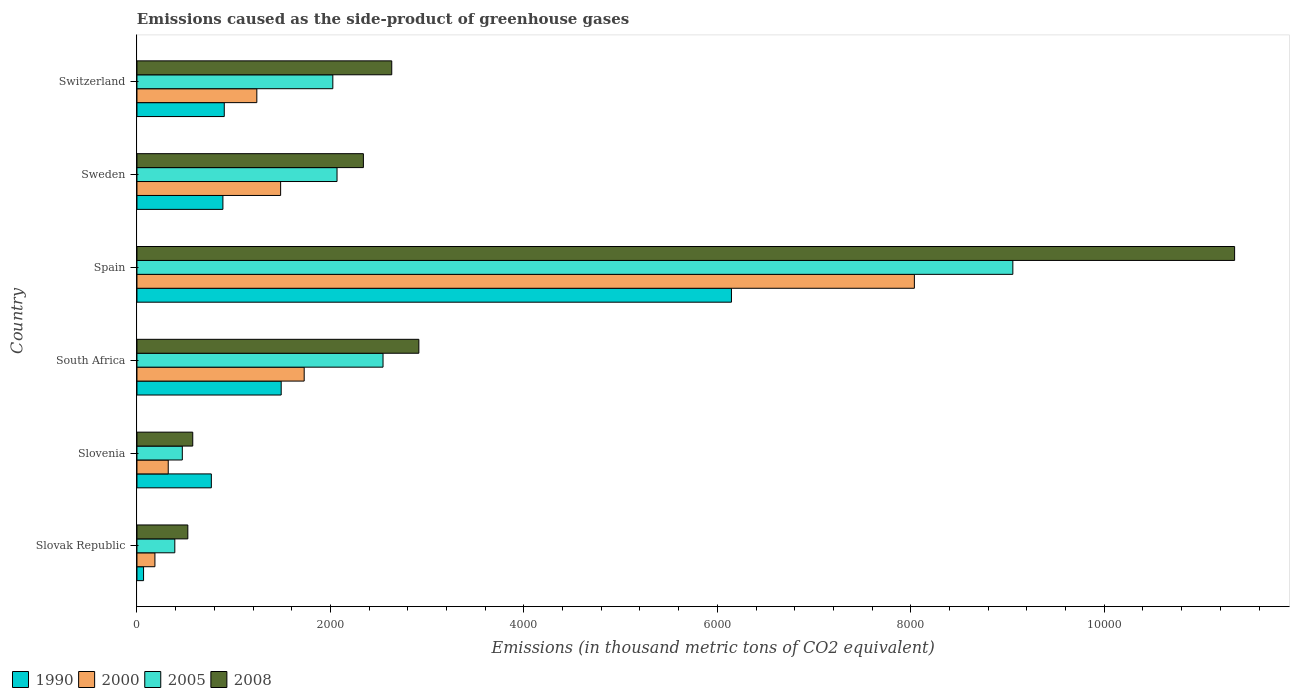How many different coloured bars are there?
Your answer should be compact. 4. Are the number of bars per tick equal to the number of legend labels?
Keep it short and to the point. Yes. How many bars are there on the 6th tick from the top?
Make the answer very short. 4. What is the label of the 6th group of bars from the top?
Your answer should be compact. Slovak Republic. In how many cases, is the number of bars for a given country not equal to the number of legend labels?
Ensure brevity in your answer.  0. What is the emissions caused as the side-product of greenhouse gases in 2005 in Switzerland?
Ensure brevity in your answer.  2025. Across all countries, what is the maximum emissions caused as the side-product of greenhouse gases in 1990?
Your answer should be compact. 6146. Across all countries, what is the minimum emissions caused as the side-product of greenhouse gases in 1990?
Your response must be concise. 68.3. In which country was the emissions caused as the side-product of greenhouse gases in 2008 maximum?
Your answer should be very brief. Spain. In which country was the emissions caused as the side-product of greenhouse gases in 1990 minimum?
Keep it short and to the point. Slovak Republic. What is the total emissions caused as the side-product of greenhouse gases in 2000 in the graph?
Provide a succinct answer. 1.30e+04. What is the difference between the emissions caused as the side-product of greenhouse gases in 2008 in Slovenia and that in Sweden?
Give a very brief answer. -1764.2. What is the difference between the emissions caused as the side-product of greenhouse gases in 2000 in Slovenia and the emissions caused as the side-product of greenhouse gases in 2008 in South Africa?
Your answer should be compact. -2591.1. What is the average emissions caused as the side-product of greenhouse gases in 2005 per country?
Your answer should be very brief. 2758.78. What is the difference between the emissions caused as the side-product of greenhouse gases in 2005 and emissions caused as the side-product of greenhouse gases in 2008 in Slovenia?
Provide a succinct answer. -107.8. In how many countries, is the emissions caused as the side-product of greenhouse gases in 2000 greater than 9200 thousand metric tons?
Provide a short and direct response. 0. What is the ratio of the emissions caused as the side-product of greenhouse gases in 1990 in Slovenia to that in South Africa?
Keep it short and to the point. 0.52. Is the emissions caused as the side-product of greenhouse gases in 2008 in Spain less than that in Switzerland?
Offer a very short reply. No. Is the difference between the emissions caused as the side-product of greenhouse gases in 2005 in Slovenia and Switzerland greater than the difference between the emissions caused as the side-product of greenhouse gases in 2008 in Slovenia and Switzerland?
Your response must be concise. Yes. What is the difference between the highest and the second highest emissions caused as the side-product of greenhouse gases in 2000?
Offer a terse response. 6308.3. What is the difference between the highest and the lowest emissions caused as the side-product of greenhouse gases in 1990?
Your answer should be very brief. 6077.7. Is the sum of the emissions caused as the side-product of greenhouse gases in 2000 in Spain and Sweden greater than the maximum emissions caused as the side-product of greenhouse gases in 2005 across all countries?
Provide a succinct answer. Yes. Is it the case that in every country, the sum of the emissions caused as the side-product of greenhouse gases in 2008 and emissions caused as the side-product of greenhouse gases in 1990 is greater than the sum of emissions caused as the side-product of greenhouse gases in 2005 and emissions caused as the side-product of greenhouse gases in 2000?
Keep it short and to the point. No. What does the 3rd bar from the bottom in Slovenia represents?
Keep it short and to the point. 2005. Is it the case that in every country, the sum of the emissions caused as the side-product of greenhouse gases in 1990 and emissions caused as the side-product of greenhouse gases in 2000 is greater than the emissions caused as the side-product of greenhouse gases in 2008?
Your response must be concise. No. How are the legend labels stacked?
Give a very brief answer. Horizontal. What is the title of the graph?
Your response must be concise. Emissions caused as the side-product of greenhouse gases. What is the label or title of the X-axis?
Ensure brevity in your answer.  Emissions (in thousand metric tons of CO2 equivalent). What is the Emissions (in thousand metric tons of CO2 equivalent) in 1990 in Slovak Republic?
Give a very brief answer. 68.3. What is the Emissions (in thousand metric tons of CO2 equivalent) of 2000 in Slovak Republic?
Offer a terse response. 185.6. What is the Emissions (in thousand metric tons of CO2 equivalent) of 2005 in Slovak Republic?
Ensure brevity in your answer.  391.3. What is the Emissions (in thousand metric tons of CO2 equivalent) in 2008 in Slovak Republic?
Provide a short and direct response. 525.8. What is the Emissions (in thousand metric tons of CO2 equivalent) in 1990 in Slovenia?
Offer a very short reply. 769. What is the Emissions (in thousand metric tons of CO2 equivalent) in 2000 in Slovenia?
Give a very brief answer. 323.3. What is the Emissions (in thousand metric tons of CO2 equivalent) in 2005 in Slovenia?
Offer a terse response. 468.9. What is the Emissions (in thousand metric tons of CO2 equivalent) of 2008 in Slovenia?
Offer a terse response. 576.7. What is the Emissions (in thousand metric tons of CO2 equivalent) of 1990 in South Africa?
Provide a short and direct response. 1491.1. What is the Emissions (in thousand metric tons of CO2 equivalent) of 2000 in South Africa?
Your answer should be compact. 1728.8. What is the Emissions (in thousand metric tons of CO2 equivalent) of 2005 in South Africa?
Keep it short and to the point. 2544. What is the Emissions (in thousand metric tons of CO2 equivalent) of 2008 in South Africa?
Provide a succinct answer. 2914.4. What is the Emissions (in thousand metric tons of CO2 equivalent) of 1990 in Spain?
Your answer should be very brief. 6146. What is the Emissions (in thousand metric tons of CO2 equivalent) of 2000 in Spain?
Offer a very short reply. 8037.1. What is the Emissions (in thousand metric tons of CO2 equivalent) of 2005 in Spain?
Offer a terse response. 9055.1. What is the Emissions (in thousand metric tons of CO2 equivalent) of 2008 in Spain?
Your answer should be very brief. 1.13e+04. What is the Emissions (in thousand metric tons of CO2 equivalent) of 1990 in Sweden?
Ensure brevity in your answer.  888.6. What is the Emissions (in thousand metric tons of CO2 equivalent) in 2000 in Sweden?
Provide a short and direct response. 1485.3. What is the Emissions (in thousand metric tons of CO2 equivalent) in 2005 in Sweden?
Give a very brief answer. 2068.4. What is the Emissions (in thousand metric tons of CO2 equivalent) of 2008 in Sweden?
Your answer should be compact. 2340.9. What is the Emissions (in thousand metric tons of CO2 equivalent) in 1990 in Switzerland?
Your response must be concise. 902.6. What is the Emissions (in thousand metric tons of CO2 equivalent) of 2000 in Switzerland?
Offer a terse response. 1239.2. What is the Emissions (in thousand metric tons of CO2 equivalent) of 2005 in Switzerland?
Your answer should be compact. 2025. What is the Emissions (in thousand metric tons of CO2 equivalent) in 2008 in Switzerland?
Provide a succinct answer. 2634.1. Across all countries, what is the maximum Emissions (in thousand metric tons of CO2 equivalent) of 1990?
Your answer should be very brief. 6146. Across all countries, what is the maximum Emissions (in thousand metric tons of CO2 equivalent) of 2000?
Your answer should be compact. 8037.1. Across all countries, what is the maximum Emissions (in thousand metric tons of CO2 equivalent) of 2005?
Make the answer very short. 9055.1. Across all countries, what is the maximum Emissions (in thousand metric tons of CO2 equivalent) of 2008?
Your response must be concise. 1.13e+04. Across all countries, what is the minimum Emissions (in thousand metric tons of CO2 equivalent) in 1990?
Keep it short and to the point. 68.3. Across all countries, what is the minimum Emissions (in thousand metric tons of CO2 equivalent) in 2000?
Your response must be concise. 185.6. Across all countries, what is the minimum Emissions (in thousand metric tons of CO2 equivalent) in 2005?
Keep it short and to the point. 391.3. Across all countries, what is the minimum Emissions (in thousand metric tons of CO2 equivalent) in 2008?
Keep it short and to the point. 525.8. What is the total Emissions (in thousand metric tons of CO2 equivalent) in 1990 in the graph?
Offer a very short reply. 1.03e+04. What is the total Emissions (in thousand metric tons of CO2 equivalent) in 2000 in the graph?
Provide a succinct answer. 1.30e+04. What is the total Emissions (in thousand metric tons of CO2 equivalent) of 2005 in the graph?
Your response must be concise. 1.66e+04. What is the total Emissions (in thousand metric tons of CO2 equivalent) of 2008 in the graph?
Your answer should be very brief. 2.03e+04. What is the difference between the Emissions (in thousand metric tons of CO2 equivalent) in 1990 in Slovak Republic and that in Slovenia?
Provide a succinct answer. -700.7. What is the difference between the Emissions (in thousand metric tons of CO2 equivalent) in 2000 in Slovak Republic and that in Slovenia?
Ensure brevity in your answer.  -137.7. What is the difference between the Emissions (in thousand metric tons of CO2 equivalent) in 2005 in Slovak Republic and that in Slovenia?
Your answer should be very brief. -77.6. What is the difference between the Emissions (in thousand metric tons of CO2 equivalent) in 2008 in Slovak Republic and that in Slovenia?
Provide a short and direct response. -50.9. What is the difference between the Emissions (in thousand metric tons of CO2 equivalent) in 1990 in Slovak Republic and that in South Africa?
Make the answer very short. -1422.8. What is the difference between the Emissions (in thousand metric tons of CO2 equivalent) in 2000 in Slovak Republic and that in South Africa?
Provide a short and direct response. -1543.2. What is the difference between the Emissions (in thousand metric tons of CO2 equivalent) in 2005 in Slovak Republic and that in South Africa?
Ensure brevity in your answer.  -2152.7. What is the difference between the Emissions (in thousand metric tons of CO2 equivalent) of 2008 in Slovak Republic and that in South Africa?
Provide a succinct answer. -2388.6. What is the difference between the Emissions (in thousand metric tons of CO2 equivalent) of 1990 in Slovak Republic and that in Spain?
Keep it short and to the point. -6077.7. What is the difference between the Emissions (in thousand metric tons of CO2 equivalent) in 2000 in Slovak Republic and that in Spain?
Provide a short and direct response. -7851.5. What is the difference between the Emissions (in thousand metric tons of CO2 equivalent) of 2005 in Slovak Republic and that in Spain?
Give a very brief answer. -8663.8. What is the difference between the Emissions (in thousand metric tons of CO2 equivalent) in 2008 in Slovak Republic and that in Spain?
Ensure brevity in your answer.  -1.08e+04. What is the difference between the Emissions (in thousand metric tons of CO2 equivalent) of 1990 in Slovak Republic and that in Sweden?
Provide a short and direct response. -820.3. What is the difference between the Emissions (in thousand metric tons of CO2 equivalent) in 2000 in Slovak Republic and that in Sweden?
Offer a terse response. -1299.7. What is the difference between the Emissions (in thousand metric tons of CO2 equivalent) of 2005 in Slovak Republic and that in Sweden?
Make the answer very short. -1677.1. What is the difference between the Emissions (in thousand metric tons of CO2 equivalent) in 2008 in Slovak Republic and that in Sweden?
Give a very brief answer. -1815.1. What is the difference between the Emissions (in thousand metric tons of CO2 equivalent) in 1990 in Slovak Republic and that in Switzerland?
Your response must be concise. -834.3. What is the difference between the Emissions (in thousand metric tons of CO2 equivalent) in 2000 in Slovak Republic and that in Switzerland?
Keep it short and to the point. -1053.6. What is the difference between the Emissions (in thousand metric tons of CO2 equivalent) in 2005 in Slovak Republic and that in Switzerland?
Offer a very short reply. -1633.7. What is the difference between the Emissions (in thousand metric tons of CO2 equivalent) of 2008 in Slovak Republic and that in Switzerland?
Your answer should be compact. -2108.3. What is the difference between the Emissions (in thousand metric tons of CO2 equivalent) of 1990 in Slovenia and that in South Africa?
Offer a very short reply. -722.1. What is the difference between the Emissions (in thousand metric tons of CO2 equivalent) of 2000 in Slovenia and that in South Africa?
Provide a succinct answer. -1405.5. What is the difference between the Emissions (in thousand metric tons of CO2 equivalent) in 2005 in Slovenia and that in South Africa?
Give a very brief answer. -2075.1. What is the difference between the Emissions (in thousand metric tons of CO2 equivalent) of 2008 in Slovenia and that in South Africa?
Make the answer very short. -2337.7. What is the difference between the Emissions (in thousand metric tons of CO2 equivalent) in 1990 in Slovenia and that in Spain?
Your answer should be compact. -5377. What is the difference between the Emissions (in thousand metric tons of CO2 equivalent) in 2000 in Slovenia and that in Spain?
Your answer should be very brief. -7713.8. What is the difference between the Emissions (in thousand metric tons of CO2 equivalent) in 2005 in Slovenia and that in Spain?
Provide a succinct answer. -8586.2. What is the difference between the Emissions (in thousand metric tons of CO2 equivalent) in 2008 in Slovenia and that in Spain?
Keep it short and to the point. -1.08e+04. What is the difference between the Emissions (in thousand metric tons of CO2 equivalent) in 1990 in Slovenia and that in Sweden?
Offer a very short reply. -119.6. What is the difference between the Emissions (in thousand metric tons of CO2 equivalent) of 2000 in Slovenia and that in Sweden?
Your response must be concise. -1162. What is the difference between the Emissions (in thousand metric tons of CO2 equivalent) in 2005 in Slovenia and that in Sweden?
Offer a very short reply. -1599.5. What is the difference between the Emissions (in thousand metric tons of CO2 equivalent) of 2008 in Slovenia and that in Sweden?
Ensure brevity in your answer.  -1764.2. What is the difference between the Emissions (in thousand metric tons of CO2 equivalent) in 1990 in Slovenia and that in Switzerland?
Provide a succinct answer. -133.6. What is the difference between the Emissions (in thousand metric tons of CO2 equivalent) in 2000 in Slovenia and that in Switzerland?
Your answer should be compact. -915.9. What is the difference between the Emissions (in thousand metric tons of CO2 equivalent) of 2005 in Slovenia and that in Switzerland?
Ensure brevity in your answer.  -1556.1. What is the difference between the Emissions (in thousand metric tons of CO2 equivalent) of 2008 in Slovenia and that in Switzerland?
Your response must be concise. -2057.4. What is the difference between the Emissions (in thousand metric tons of CO2 equivalent) in 1990 in South Africa and that in Spain?
Offer a very short reply. -4654.9. What is the difference between the Emissions (in thousand metric tons of CO2 equivalent) of 2000 in South Africa and that in Spain?
Make the answer very short. -6308.3. What is the difference between the Emissions (in thousand metric tons of CO2 equivalent) in 2005 in South Africa and that in Spain?
Ensure brevity in your answer.  -6511.1. What is the difference between the Emissions (in thousand metric tons of CO2 equivalent) in 2008 in South Africa and that in Spain?
Make the answer very short. -8433.4. What is the difference between the Emissions (in thousand metric tons of CO2 equivalent) in 1990 in South Africa and that in Sweden?
Keep it short and to the point. 602.5. What is the difference between the Emissions (in thousand metric tons of CO2 equivalent) in 2000 in South Africa and that in Sweden?
Offer a very short reply. 243.5. What is the difference between the Emissions (in thousand metric tons of CO2 equivalent) of 2005 in South Africa and that in Sweden?
Your response must be concise. 475.6. What is the difference between the Emissions (in thousand metric tons of CO2 equivalent) of 2008 in South Africa and that in Sweden?
Ensure brevity in your answer.  573.5. What is the difference between the Emissions (in thousand metric tons of CO2 equivalent) in 1990 in South Africa and that in Switzerland?
Give a very brief answer. 588.5. What is the difference between the Emissions (in thousand metric tons of CO2 equivalent) of 2000 in South Africa and that in Switzerland?
Make the answer very short. 489.6. What is the difference between the Emissions (in thousand metric tons of CO2 equivalent) of 2005 in South Africa and that in Switzerland?
Give a very brief answer. 519. What is the difference between the Emissions (in thousand metric tons of CO2 equivalent) in 2008 in South Africa and that in Switzerland?
Ensure brevity in your answer.  280.3. What is the difference between the Emissions (in thousand metric tons of CO2 equivalent) of 1990 in Spain and that in Sweden?
Make the answer very short. 5257.4. What is the difference between the Emissions (in thousand metric tons of CO2 equivalent) of 2000 in Spain and that in Sweden?
Make the answer very short. 6551.8. What is the difference between the Emissions (in thousand metric tons of CO2 equivalent) in 2005 in Spain and that in Sweden?
Your response must be concise. 6986.7. What is the difference between the Emissions (in thousand metric tons of CO2 equivalent) in 2008 in Spain and that in Sweden?
Offer a terse response. 9006.9. What is the difference between the Emissions (in thousand metric tons of CO2 equivalent) in 1990 in Spain and that in Switzerland?
Offer a terse response. 5243.4. What is the difference between the Emissions (in thousand metric tons of CO2 equivalent) of 2000 in Spain and that in Switzerland?
Your response must be concise. 6797.9. What is the difference between the Emissions (in thousand metric tons of CO2 equivalent) of 2005 in Spain and that in Switzerland?
Keep it short and to the point. 7030.1. What is the difference between the Emissions (in thousand metric tons of CO2 equivalent) in 2008 in Spain and that in Switzerland?
Provide a short and direct response. 8713.7. What is the difference between the Emissions (in thousand metric tons of CO2 equivalent) in 1990 in Sweden and that in Switzerland?
Your answer should be very brief. -14. What is the difference between the Emissions (in thousand metric tons of CO2 equivalent) in 2000 in Sweden and that in Switzerland?
Offer a terse response. 246.1. What is the difference between the Emissions (in thousand metric tons of CO2 equivalent) of 2005 in Sweden and that in Switzerland?
Your response must be concise. 43.4. What is the difference between the Emissions (in thousand metric tons of CO2 equivalent) in 2008 in Sweden and that in Switzerland?
Your answer should be compact. -293.2. What is the difference between the Emissions (in thousand metric tons of CO2 equivalent) in 1990 in Slovak Republic and the Emissions (in thousand metric tons of CO2 equivalent) in 2000 in Slovenia?
Give a very brief answer. -255. What is the difference between the Emissions (in thousand metric tons of CO2 equivalent) of 1990 in Slovak Republic and the Emissions (in thousand metric tons of CO2 equivalent) of 2005 in Slovenia?
Your answer should be compact. -400.6. What is the difference between the Emissions (in thousand metric tons of CO2 equivalent) in 1990 in Slovak Republic and the Emissions (in thousand metric tons of CO2 equivalent) in 2008 in Slovenia?
Your answer should be compact. -508.4. What is the difference between the Emissions (in thousand metric tons of CO2 equivalent) in 2000 in Slovak Republic and the Emissions (in thousand metric tons of CO2 equivalent) in 2005 in Slovenia?
Give a very brief answer. -283.3. What is the difference between the Emissions (in thousand metric tons of CO2 equivalent) of 2000 in Slovak Republic and the Emissions (in thousand metric tons of CO2 equivalent) of 2008 in Slovenia?
Give a very brief answer. -391.1. What is the difference between the Emissions (in thousand metric tons of CO2 equivalent) of 2005 in Slovak Republic and the Emissions (in thousand metric tons of CO2 equivalent) of 2008 in Slovenia?
Ensure brevity in your answer.  -185.4. What is the difference between the Emissions (in thousand metric tons of CO2 equivalent) of 1990 in Slovak Republic and the Emissions (in thousand metric tons of CO2 equivalent) of 2000 in South Africa?
Your response must be concise. -1660.5. What is the difference between the Emissions (in thousand metric tons of CO2 equivalent) of 1990 in Slovak Republic and the Emissions (in thousand metric tons of CO2 equivalent) of 2005 in South Africa?
Your response must be concise. -2475.7. What is the difference between the Emissions (in thousand metric tons of CO2 equivalent) of 1990 in Slovak Republic and the Emissions (in thousand metric tons of CO2 equivalent) of 2008 in South Africa?
Your response must be concise. -2846.1. What is the difference between the Emissions (in thousand metric tons of CO2 equivalent) of 2000 in Slovak Republic and the Emissions (in thousand metric tons of CO2 equivalent) of 2005 in South Africa?
Provide a short and direct response. -2358.4. What is the difference between the Emissions (in thousand metric tons of CO2 equivalent) in 2000 in Slovak Republic and the Emissions (in thousand metric tons of CO2 equivalent) in 2008 in South Africa?
Your answer should be compact. -2728.8. What is the difference between the Emissions (in thousand metric tons of CO2 equivalent) of 2005 in Slovak Republic and the Emissions (in thousand metric tons of CO2 equivalent) of 2008 in South Africa?
Keep it short and to the point. -2523.1. What is the difference between the Emissions (in thousand metric tons of CO2 equivalent) in 1990 in Slovak Republic and the Emissions (in thousand metric tons of CO2 equivalent) in 2000 in Spain?
Your answer should be compact. -7968.8. What is the difference between the Emissions (in thousand metric tons of CO2 equivalent) in 1990 in Slovak Republic and the Emissions (in thousand metric tons of CO2 equivalent) in 2005 in Spain?
Give a very brief answer. -8986.8. What is the difference between the Emissions (in thousand metric tons of CO2 equivalent) in 1990 in Slovak Republic and the Emissions (in thousand metric tons of CO2 equivalent) in 2008 in Spain?
Your answer should be compact. -1.13e+04. What is the difference between the Emissions (in thousand metric tons of CO2 equivalent) of 2000 in Slovak Republic and the Emissions (in thousand metric tons of CO2 equivalent) of 2005 in Spain?
Your answer should be very brief. -8869.5. What is the difference between the Emissions (in thousand metric tons of CO2 equivalent) of 2000 in Slovak Republic and the Emissions (in thousand metric tons of CO2 equivalent) of 2008 in Spain?
Your answer should be compact. -1.12e+04. What is the difference between the Emissions (in thousand metric tons of CO2 equivalent) of 2005 in Slovak Republic and the Emissions (in thousand metric tons of CO2 equivalent) of 2008 in Spain?
Offer a very short reply. -1.10e+04. What is the difference between the Emissions (in thousand metric tons of CO2 equivalent) of 1990 in Slovak Republic and the Emissions (in thousand metric tons of CO2 equivalent) of 2000 in Sweden?
Make the answer very short. -1417. What is the difference between the Emissions (in thousand metric tons of CO2 equivalent) in 1990 in Slovak Republic and the Emissions (in thousand metric tons of CO2 equivalent) in 2005 in Sweden?
Provide a succinct answer. -2000.1. What is the difference between the Emissions (in thousand metric tons of CO2 equivalent) of 1990 in Slovak Republic and the Emissions (in thousand metric tons of CO2 equivalent) of 2008 in Sweden?
Offer a very short reply. -2272.6. What is the difference between the Emissions (in thousand metric tons of CO2 equivalent) in 2000 in Slovak Republic and the Emissions (in thousand metric tons of CO2 equivalent) in 2005 in Sweden?
Ensure brevity in your answer.  -1882.8. What is the difference between the Emissions (in thousand metric tons of CO2 equivalent) of 2000 in Slovak Republic and the Emissions (in thousand metric tons of CO2 equivalent) of 2008 in Sweden?
Offer a very short reply. -2155.3. What is the difference between the Emissions (in thousand metric tons of CO2 equivalent) of 2005 in Slovak Republic and the Emissions (in thousand metric tons of CO2 equivalent) of 2008 in Sweden?
Provide a short and direct response. -1949.6. What is the difference between the Emissions (in thousand metric tons of CO2 equivalent) in 1990 in Slovak Republic and the Emissions (in thousand metric tons of CO2 equivalent) in 2000 in Switzerland?
Offer a very short reply. -1170.9. What is the difference between the Emissions (in thousand metric tons of CO2 equivalent) in 1990 in Slovak Republic and the Emissions (in thousand metric tons of CO2 equivalent) in 2005 in Switzerland?
Offer a very short reply. -1956.7. What is the difference between the Emissions (in thousand metric tons of CO2 equivalent) in 1990 in Slovak Republic and the Emissions (in thousand metric tons of CO2 equivalent) in 2008 in Switzerland?
Keep it short and to the point. -2565.8. What is the difference between the Emissions (in thousand metric tons of CO2 equivalent) in 2000 in Slovak Republic and the Emissions (in thousand metric tons of CO2 equivalent) in 2005 in Switzerland?
Your response must be concise. -1839.4. What is the difference between the Emissions (in thousand metric tons of CO2 equivalent) in 2000 in Slovak Republic and the Emissions (in thousand metric tons of CO2 equivalent) in 2008 in Switzerland?
Your response must be concise. -2448.5. What is the difference between the Emissions (in thousand metric tons of CO2 equivalent) in 2005 in Slovak Republic and the Emissions (in thousand metric tons of CO2 equivalent) in 2008 in Switzerland?
Your response must be concise. -2242.8. What is the difference between the Emissions (in thousand metric tons of CO2 equivalent) of 1990 in Slovenia and the Emissions (in thousand metric tons of CO2 equivalent) of 2000 in South Africa?
Your answer should be very brief. -959.8. What is the difference between the Emissions (in thousand metric tons of CO2 equivalent) in 1990 in Slovenia and the Emissions (in thousand metric tons of CO2 equivalent) in 2005 in South Africa?
Make the answer very short. -1775. What is the difference between the Emissions (in thousand metric tons of CO2 equivalent) in 1990 in Slovenia and the Emissions (in thousand metric tons of CO2 equivalent) in 2008 in South Africa?
Offer a very short reply. -2145.4. What is the difference between the Emissions (in thousand metric tons of CO2 equivalent) in 2000 in Slovenia and the Emissions (in thousand metric tons of CO2 equivalent) in 2005 in South Africa?
Provide a short and direct response. -2220.7. What is the difference between the Emissions (in thousand metric tons of CO2 equivalent) in 2000 in Slovenia and the Emissions (in thousand metric tons of CO2 equivalent) in 2008 in South Africa?
Your answer should be very brief. -2591.1. What is the difference between the Emissions (in thousand metric tons of CO2 equivalent) in 2005 in Slovenia and the Emissions (in thousand metric tons of CO2 equivalent) in 2008 in South Africa?
Ensure brevity in your answer.  -2445.5. What is the difference between the Emissions (in thousand metric tons of CO2 equivalent) of 1990 in Slovenia and the Emissions (in thousand metric tons of CO2 equivalent) of 2000 in Spain?
Ensure brevity in your answer.  -7268.1. What is the difference between the Emissions (in thousand metric tons of CO2 equivalent) in 1990 in Slovenia and the Emissions (in thousand metric tons of CO2 equivalent) in 2005 in Spain?
Your answer should be compact. -8286.1. What is the difference between the Emissions (in thousand metric tons of CO2 equivalent) of 1990 in Slovenia and the Emissions (in thousand metric tons of CO2 equivalent) of 2008 in Spain?
Offer a very short reply. -1.06e+04. What is the difference between the Emissions (in thousand metric tons of CO2 equivalent) of 2000 in Slovenia and the Emissions (in thousand metric tons of CO2 equivalent) of 2005 in Spain?
Offer a terse response. -8731.8. What is the difference between the Emissions (in thousand metric tons of CO2 equivalent) of 2000 in Slovenia and the Emissions (in thousand metric tons of CO2 equivalent) of 2008 in Spain?
Your response must be concise. -1.10e+04. What is the difference between the Emissions (in thousand metric tons of CO2 equivalent) of 2005 in Slovenia and the Emissions (in thousand metric tons of CO2 equivalent) of 2008 in Spain?
Your answer should be very brief. -1.09e+04. What is the difference between the Emissions (in thousand metric tons of CO2 equivalent) in 1990 in Slovenia and the Emissions (in thousand metric tons of CO2 equivalent) in 2000 in Sweden?
Provide a short and direct response. -716.3. What is the difference between the Emissions (in thousand metric tons of CO2 equivalent) of 1990 in Slovenia and the Emissions (in thousand metric tons of CO2 equivalent) of 2005 in Sweden?
Your answer should be compact. -1299.4. What is the difference between the Emissions (in thousand metric tons of CO2 equivalent) in 1990 in Slovenia and the Emissions (in thousand metric tons of CO2 equivalent) in 2008 in Sweden?
Give a very brief answer. -1571.9. What is the difference between the Emissions (in thousand metric tons of CO2 equivalent) of 2000 in Slovenia and the Emissions (in thousand metric tons of CO2 equivalent) of 2005 in Sweden?
Offer a terse response. -1745.1. What is the difference between the Emissions (in thousand metric tons of CO2 equivalent) in 2000 in Slovenia and the Emissions (in thousand metric tons of CO2 equivalent) in 2008 in Sweden?
Provide a short and direct response. -2017.6. What is the difference between the Emissions (in thousand metric tons of CO2 equivalent) in 2005 in Slovenia and the Emissions (in thousand metric tons of CO2 equivalent) in 2008 in Sweden?
Ensure brevity in your answer.  -1872. What is the difference between the Emissions (in thousand metric tons of CO2 equivalent) in 1990 in Slovenia and the Emissions (in thousand metric tons of CO2 equivalent) in 2000 in Switzerland?
Offer a terse response. -470.2. What is the difference between the Emissions (in thousand metric tons of CO2 equivalent) in 1990 in Slovenia and the Emissions (in thousand metric tons of CO2 equivalent) in 2005 in Switzerland?
Make the answer very short. -1256. What is the difference between the Emissions (in thousand metric tons of CO2 equivalent) in 1990 in Slovenia and the Emissions (in thousand metric tons of CO2 equivalent) in 2008 in Switzerland?
Offer a terse response. -1865.1. What is the difference between the Emissions (in thousand metric tons of CO2 equivalent) in 2000 in Slovenia and the Emissions (in thousand metric tons of CO2 equivalent) in 2005 in Switzerland?
Offer a very short reply. -1701.7. What is the difference between the Emissions (in thousand metric tons of CO2 equivalent) of 2000 in Slovenia and the Emissions (in thousand metric tons of CO2 equivalent) of 2008 in Switzerland?
Offer a very short reply. -2310.8. What is the difference between the Emissions (in thousand metric tons of CO2 equivalent) of 2005 in Slovenia and the Emissions (in thousand metric tons of CO2 equivalent) of 2008 in Switzerland?
Give a very brief answer. -2165.2. What is the difference between the Emissions (in thousand metric tons of CO2 equivalent) in 1990 in South Africa and the Emissions (in thousand metric tons of CO2 equivalent) in 2000 in Spain?
Provide a short and direct response. -6546. What is the difference between the Emissions (in thousand metric tons of CO2 equivalent) of 1990 in South Africa and the Emissions (in thousand metric tons of CO2 equivalent) of 2005 in Spain?
Your answer should be compact. -7564. What is the difference between the Emissions (in thousand metric tons of CO2 equivalent) of 1990 in South Africa and the Emissions (in thousand metric tons of CO2 equivalent) of 2008 in Spain?
Give a very brief answer. -9856.7. What is the difference between the Emissions (in thousand metric tons of CO2 equivalent) in 2000 in South Africa and the Emissions (in thousand metric tons of CO2 equivalent) in 2005 in Spain?
Offer a very short reply. -7326.3. What is the difference between the Emissions (in thousand metric tons of CO2 equivalent) in 2000 in South Africa and the Emissions (in thousand metric tons of CO2 equivalent) in 2008 in Spain?
Make the answer very short. -9619. What is the difference between the Emissions (in thousand metric tons of CO2 equivalent) of 2005 in South Africa and the Emissions (in thousand metric tons of CO2 equivalent) of 2008 in Spain?
Offer a terse response. -8803.8. What is the difference between the Emissions (in thousand metric tons of CO2 equivalent) of 1990 in South Africa and the Emissions (in thousand metric tons of CO2 equivalent) of 2005 in Sweden?
Make the answer very short. -577.3. What is the difference between the Emissions (in thousand metric tons of CO2 equivalent) of 1990 in South Africa and the Emissions (in thousand metric tons of CO2 equivalent) of 2008 in Sweden?
Give a very brief answer. -849.8. What is the difference between the Emissions (in thousand metric tons of CO2 equivalent) of 2000 in South Africa and the Emissions (in thousand metric tons of CO2 equivalent) of 2005 in Sweden?
Keep it short and to the point. -339.6. What is the difference between the Emissions (in thousand metric tons of CO2 equivalent) in 2000 in South Africa and the Emissions (in thousand metric tons of CO2 equivalent) in 2008 in Sweden?
Offer a very short reply. -612.1. What is the difference between the Emissions (in thousand metric tons of CO2 equivalent) in 2005 in South Africa and the Emissions (in thousand metric tons of CO2 equivalent) in 2008 in Sweden?
Your response must be concise. 203.1. What is the difference between the Emissions (in thousand metric tons of CO2 equivalent) of 1990 in South Africa and the Emissions (in thousand metric tons of CO2 equivalent) of 2000 in Switzerland?
Ensure brevity in your answer.  251.9. What is the difference between the Emissions (in thousand metric tons of CO2 equivalent) of 1990 in South Africa and the Emissions (in thousand metric tons of CO2 equivalent) of 2005 in Switzerland?
Make the answer very short. -533.9. What is the difference between the Emissions (in thousand metric tons of CO2 equivalent) in 1990 in South Africa and the Emissions (in thousand metric tons of CO2 equivalent) in 2008 in Switzerland?
Give a very brief answer. -1143. What is the difference between the Emissions (in thousand metric tons of CO2 equivalent) in 2000 in South Africa and the Emissions (in thousand metric tons of CO2 equivalent) in 2005 in Switzerland?
Provide a short and direct response. -296.2. What is the difference between the Emissions (in thousand metric tons of CO2 equivalent) in 2000 in South Africa and the Emissions (in thousand metric tons of CO2 equivalent) in 2008 in Switzerland?
Your answer should be compact. -905.3. What is the difference between the Emissions (in thousand metric tons of CO2 equivalent) of 2005 in South Africa and the Emissions (in thousand metric tons of CO2 equivalent) of 2008 in Switzerland?
Ensure brevity in your answer.  -90.1. What is the difference between the Emissions (in thousand metric tons of CO2 equivalent) in 1990 in Spain and the Emissions (in thousand metric tons of CO2 equivalent) in 2000 in Sweden?
Give a very brief answer. 4660.7. What is the difference between the Emissions (in thousand metric tons of CO2 equivalent) of 1990 in Spain and the Emissions (in thousand metric tons of CO2 equivalent) of 2005 in Sweden?
Ensure brevity in your answer.  4077.6. What is the difference between the Emissions (in thousand metric tons of CO2 equivalent) of 1990 in Spain and the Emissions (in thousand metric tons of CO2 equivalent) of 2008 in Sweden?
Give a very brief answer. 3805.1. What is the difference between the Emissions (in thousand metric tons of CO2 equivalent) in 2000 in Spain and the Emissions (in thousand metric tons of CO2 equivalent) in 2005 in Sweden?
Give a very brief answer. 5968.7. What is the difference between the Emissions (in thousand metric tons of CO2 equivalent) of 2000 in Spain and the Emissions (in thousand metric tons of CO2 equivalent) of 2008 in Sweden?
Give a very brief answer. 5696.2. What is the difference between the Emissions (in thousand metric tons of CO2 equivalent) of 2005 in Spain and the Emissions (in thousand metric tons of CO2 equivalent) of 2008 in Sweden?
Give a very brief answer. 6714.2. What is the difference between the Emissions (in thousand metric tons of CO2 equivalent) of 1990 in Spain and the Emissions (in thousand metric tons of CO2 equivalent) of 2000 in Switzerland?
Ensure brevity in your answer.  4906.8. What is the difference between the Emissions (in thousand metric tons of CO2 equivalent) in 1990 in Spain and the Emissions (in thousand metric tons of CO2 equivalent) in 2005 in Switzerland?
Make the answer very short. 4121. What is the difference between the Emissions (in thousand metric tons of CO2 equivalent) of 1990 in Spain and the Emissions (in thousand metric tons of CO2 equivalent) of 2008 in Switzerland?
Your answer should be very brief. 3511.9. What is the difference between the Emissions (in thousand metric tons of CO2 equivalent) of 2000 in Spain and the Emissions (in thousand metric tons of CO2 equivalent) of 2005 in Switzerland?
Make the answer very short. 6012.1. What is the difference between the Emissions (in thousand metric tons of CO2 equivalent) in 2000 in Spain and the Emissions (in thousand metric tons of CO2 equivalent) in 2008 in Switzerland?
Offer a terse response. 5403. What is the difference between the Emissions (in thousand metric tons of CO2 equivalent) of 2005 in Spain and the Emissions (in thousand metric tons of CO2 equivalent) of 2008 in Switzerland?
Provide a succinct answer. 6421. What is the difference between the Emissions (in thousand metric tons of CO2 equivalent) in 1990 in Sweden and the Emissions (in thousand metric tons of CO2 equivalent) in 2000 in Switzerland?
Keep it short and to the point. -350.6. What is the difference between the Emissions (in thousand metric tons of CO2 equivalent) in 1990 in Sweden and the Emissions (in thousand metric tons of CO2 equivalent) in 2005 in Switzerland?
Your answer should be compact. -1136.4. What is the difference between the Emissions (in thousand metric tons of CO2 equivalent) of 1990 in Sweden and the Emissions (in thousand metric tons of CO2 equivalent) of 2008 in Switzerland?
Give a very brief answer. -1745.5. What is the difference between the Emissions (in thousand metric tons of CO2 equivalent) in 2000 in Sweden and the Emissions (in thousand metric tons of CO2 equivalent) in 2005 in Switzerland?
Your answer should be very brief. -539.7. What is the difference between the Emissions (in thousand metric tons of CO2 equivalent) in 2000 in Sweden and the Emissions (in thousand metric tons of CO2 equivalent) in 2008 in Switzerland?
Your answer should be very brief. -1148.8. What is the difference between the Emissions (in thousand metric tons of CO2 equivalent) of 2005 in Sweden and the Emissions (in thousand metric tons of CO2 equivalent) of 2008 in Switzerland?
Keep it short and to the point. -565.7. What is the average Emissions (in thousand metric tons of CO2 equivalent) of 1990 per country?
Offer a terse response. 1710.93. What is the average Emissions (in thousand metric tons of CO2 equivalent) of 2000 per country?
Your answer should be very brief. 2166.55. What is the average Emissions (in thousand metric tons of CO2 equivalent) of 2005 per country?
Make the answer very short. 2758.78. What is the average Emissions (in thousand metric tons of CO2 equivalent) in 2008 per country?
Keep it short and to the point. 3389.95. What is the difference between the Emissions (in thousand metric tons of CO2 equivalent) of 1990 and Emissions (in thousand metric tons of CO2 equivalent) of 2000 in Slovak Republic?
Your response must be concise. -117.3. What is the difference between the Emissions (in thousand metric tons of CO2 equivalent) in 1990 and Emissions (in thousand metric tons of CO2 equivalent) in 2005 in Slovak Republic?
Make the answer very short. -323. What is the difference between the Emissions (in thousand metric tons of CO2 equivalent) of 1990 and Emissions (in thousand metric tons of CO2 equivalent) of 2008 in Slovak Republic?
Keep it short and to the point. -457.5. What is the difference between the Emissions (in thousand metric tons of CO2 equivalent) of 2000 and Emissions (in thousand metric tons of CO2 equivalent) of 2005 in Slovak Republic?
Give a very brief answer. -205.7. What is the difference between the Emissions (in thousand metric tons of CO2 equivalent) of 2000 and Emissions (in thousand metric tons of CO2 equivalent) of 2008 in Slovak Republic?
Give a very brief answer. -340.2. What is the difference between the Emissions (in thousand metric tons of CO2 equivalent) in 2005 and Emissions (in thousand metric tons of CO2 equivalent) in 2008 in Slovak Republic?
Your answer should be very brief. -134.5. What is the difference between the Emissions (in thousand metric tons of CO2 equivalent) of 1990 and Emissions (in thousand metric tons of CO2 equivalent) of 2000 in Slovenia?
Offer a very short reply. 445.7. What is the difference between the Emissions (in thousand metric tons of CO2 equivalent) in 1990 and Emissions (in thousand metric tons of CO2 equivalent) in 2005 in Slovenia?
Give a very brief answer. 300.1. What is the difference between the Emissions (in thousand metric tons of CO2 equivalent) of 1990 and Emissions (in thousand metric tons of CO2 equivalent) of 2008 in Slovenia?
Provide a short and direct response. 192.3. What is the difference between the Emissions (in thousand metric tons of CO2 equivalent) in 2000 and Emissions (in thousand metric tons of CO2 equivalent) in 2005 in Slovenia?
Your response must be concise. -145.6. What is the difference between the Emissions (in thousand metric tons of CO2 equivalent) in 2000 and Emissions (in thousand metric tons of CO2 equivalent) in 2008 in Slovenia?
Give a very brief answer. -253.4. What is the difference between the Emissions (in thousand metric tons of CO2 equivalent) in 2005 and Emissions (in thousand metric tons of CO2 equivalent) in 2008 in Slovenia?
Make the answer very short. -107.8. What is the difference between the Emissions (in thousand metric tons of CO2 equivalent) of 1990 and Emissions (in thousand metric tons of CO2 equivalent) of 2000 in South Africa?
Give a very brief answer. -237.7. What is the difference between the Emissions (in thousand metric tons of CO2 equivalent) in 1990 and Emissions (in thousand metric tons of CO2 equivalent) in 2005 in South Africa?
Offer a terse response. -1052.9. What is the difference between the Emissions (in thousand metric tons of CO2 equivalent) in 1990 and Emissions (in thousand metric tons of CO2 equivalent) in 2008 in South Africa?
Offer a very short reply. -1423.3. What is the difference between the Emissions (in thousand metric tons of CO2 equivalent) in 2000 and Emissions (in thousand metric tons of CO2 equivalent) in 2005 in South Africa?
Your answer should be very brief. -815.2. What is the difference between the Emissions (in thousand metric tons of CO2 equivalent) in 2000 and Emissions (in thousand metric tons of CO2 equivalent) in 2008 in South Africa?
Your answer should be very brief. -1185.6. What is the difference between the Emissions (in thousand metric tons of CO2 equivalent) of 2005 and Emissions (in thousand metric tons of CO2 equivalent) of 2008 in South Africa?
Offer a terse response. -370.4. What is the difference between the Emissions (in thousand metric tons of CO2 equivalent) in 1990 and Emissions (in thousand metric tons of CO2 equivalent) in 2000 in Spain?
Your answer should be compact. -1891.1. What is the difference between the Emissions (in thousand metric tons of CO2 equivalent) of 1990 and Emissions (in thousand metric tons of CO2 equivalent) of 2005 in Spain?
Your response must be concise. -2909.1. What is the difference between the Emissions (in thousand metric tons of CO2 equivalent) in 1990 and Emissions (in thousand metric tons of CO2 equivalent) in 2008 in Spain?
Give a very brief answer. -5201.8. What is the difference between the Emissions (in thousand metric tons of CO2 equivalent) of 2000 and Emissions (in thousand metric tons of CO2 equivalent) of 2005 in Spain?
Your answer should be compact. -1018. What is the difference between the Emissions (in thousand metric tons of CO2 equivalent) of 2000 and Emissions (in thousand metric tons of CO2 equivalent) of 2008 in Spain?
Ensure brevity in your answer.  -3310.7. What is the difference between the Emissions (in thousand metric tons of CO2 equivalent) in 2005 and Emissions (in thousand metric tons of CO2 equivalent) in 2008 in Spain?
Your response must be concise. -2292.7. What is the difference between the Emissions (in thousand metric tons of CO2 equivalent) in 1990 and Emissions (in thousand metric tons of CO2 equivalent) in 2000 in Sweden?
Your answer should be compact. -596.7. What is the difference between the Emissions (in thousand metric tons of CO2 equivalent) in 1990 and Emissions (in thousand metric tons of CO2 equivalent) in 2005 in Sweden?
Your answer should be compact. -1179.8. What is the difference between the Emissions (in thousand metric tons of CO2 equivalent) of 1990 and Emissions (in thousand metric tons of CO2 equivalent) of 2008 in Sweden?
Your response must be concise. -1452.3. What is the difference between the Emissions (in thousand metric tons of CO2 equivalent) in 2000 and Emissions (in thousand metric tons of CO2 equivalent) in 2005 in Sweden?
Your answer should be compact. -583.1. What is the difference between the Emissions (in thousand metric tons of CO2 equivalent) in 2000 and Emissions (in thousand metric tons of CO2 equivalent) in 2008 in Sweden?
Ensure brevity in your answer.  -855.6. What is the difference between the Emissions (in thousand metric tons of CO2 equivalent) of 2005 and Emissions (in thousand metric tons of CO2 equivalent) of 2008 in Sweden?
Make the answer very short. -272.5. What is the difference between the Emissions (in thousand metric tons of CO2 equivalent) of 1990 and Emissions (in thousand metric tons of CO2 equivalent) of 2000 in Switzerland?
Your response must be concise. -336.6. What is the difference between the Emissions (in thousand metric tons of CO2 equivalent) of 1990 and Emissions (in thousand metric tons of CO2 equivalent) of 2005 in Switzerland?
Keep it short and to the point. -1122.4. What is the difference between the Emissions (in thousand metric tons of CO2 equivalent) of 1990 and Emissions (in thousand metric tons of CO2 equivalent) of 2008 in Switzerland?
Ensure brevity in your answer.  -1731.5. What is the difference between the Emissions (in thousand metric tons of CO2 equivalent) in 2000 and Emissions (in thousand metric tons of CO2 equivalent) in 2005 in Switzerland?
Keep it short and to the point. -785.8. What is the difference between the Emissions (in thousand metric tons of CO2 equivalent) of 2000 and Emissions (in thousand metric tons of CO2 equivalent) of 2008 in Switzerland?
Give a very brief answer. -1394.9. What is the difference between the Emissions (in thousand metric tons of CO2 equivalent) in 2005 and Emissions (in thousand metric tons of CO2 equivalent) in 2008 in Switzerland?
Keep it short and to the point. -609.1. What is the ratio of the Emissions (in thousand metric tons of CO2 equivalent) of 1990 in Slovak Republic to that in Slovenia?
Offer a very short reply. 0.09. What is the ratio of the Emissions (in thousand metric tons of CO2 equivalent) in 2000 in Slovak Republic to that in Slovenia?
Offer a terse response. 0.57. What is the ratio of the Emissions (in thousand metric tons of CO2 equivalent) of 2005 in Slovak Republic to that in Slovenia?
Make the answer very short. 0.83. What is the ratio of the Emissions (in thousand metric tons of CO2 equivalent) of 2008 in Slovak Republic to that in Slovenia?
Your answer should be compact. 0.91. What is the ratio of the Emissions (in thousand metric tons of CO2 equivalent) in 1990 in Slovak Republic to that in South Africa?
Make the answer very short. 0.05. What is the ratio of the Emissions (in thousand metric tons of CO2 equivalent) in 2000 in Slovak Republic to that in South Africa?
Your answer should be compact. 0.11. What is the ratio of the Emissions (in thousand metric tons of CO2 equivalent) of 2005 in Slovak Republic to that in South Africa?
Give a very brief answer. 0.15. What is the ratio of the Emissions (in thousand metric tons of CO2 equivalent) of 2008 in Slovak Republic to that in South Africa?
Provide a succinct answer. 0.18. What is the ratio of the Emissions (in thousand metric tons of CO2 equivalent) of 1990 in Slovak Republic to that in Spain?
Your answer should be compact. 0.01. What is the ratio of the Emissions (in thousand metric tons of CO2 equivalent) in 2000 in Slovak Republic to that in Spain?
Your answer should be very brief. 0.02. What is the ratio of the Emissions (in thousand metric tons of CO2 equivalent) of 2005 in Slovak Republic to that in Spain?
Give a very brief answer. 0.04. What is the ratio of the Emissions (in thousand metric tons of CO2 equivalent) of 2008 in Slovak Republic to that in Spain?
Provide a succinct answer. 0.05. What is the ratio of the Emissions (in thousand metric tons of CO2 equivalent) in 1990 in Slovak Republic to that in Sweden?
Your response must be concise. 0.08. What is the ratio of the Emissions (in thousand metric tons of CO2 equivalent) of 2005 in Slovak Republic to that in Sweden?
Your response must be concise. 0.19. What is the ratio of the Emissions (in thousand metric tons of CO2 equivalent) in 2008 in Slovak Republic to that in Sweden?
Your answer should be compact. 0.22. What is the ratio of the Emissions (in thousand metric tons of CO2 equivalent) in 1990 in Slovak Republic to that in Switzerland?
Your answer should be compact. 0.08. What is the ratio of the Emissions (in thousand metric tons of CO2 equivalent) in 2000 in Slovak Republic to that in Switzerland?
Give a very brief answer. 0.15. What is the ratio of the Emissions (in thousand metric tons of CO2 equivalent) of 2005 in Slovak Republic to that in Switzerland?
Keep it short and to the point. 0.19. What is the ratio of the Emissions (in thousand metric tons of CO2 equivalent) in 2008 in Slovak Republic to that in Switzerland?
Keep it short and to the point. 0.2. What is the ratio of the Emissions (in thousand metric tons of CO2 equivalent) in 1990 in Slovenia to that in South Africa?
Keep it short and to the point. 0.52. What is the ratio of the Emissions (in thousand metric tons of CO2 equivalent) in 2000 in Slovenia to that in South Africa?
Make the answer very short. 0.19. What is the ratio of the Emissions (in thousand metric tons of CO2 equivalent) of 2005 in Slovenia to that in South Africa?
Provide a succinct answer. 0.18. What is the ratio of the Emissions (in thousand metric tons of CO2 equivalent) of 2008 in Slovenia to that in South Africa?
Your answer should be compact. 0.2. What is the ratio of the Emissions (in thousand metric tons of CO2 equivalent) in 1990 in Slovenia to that in Spain?
Keep it short and to the point. 0.13. What is the ratio of the Emissions (in thousand metric tons of CO2 equivalent) of 2000 in Slovenia to that in Spain?
Offer a terse response. 0.04. What is the ratio of the Emissions (in thousand metric tons of CO2 equivalent) of 2005 in Slovenia to that in Spain?
Offer a very short reply. 0.05. What is the ratio of the Emissions (in thousand metric tons of CO2 equivalent) of 2008 in Slovenia to that in Spain?
Your answer should be very brief. 0.05. What is the ratio of the Emissions (in thousand metric tons of CO2 equivalent) of 1990 in Slovenia to that in Sweden?
Keep it short and to the point. 0.87. What is the ratio of the Emissions (in thousand metric tons of CO2 equivalent) of 2000 in Slovenia to that in Sweden?
Offer a very short reply. 0.22. What is the ratio of the Emissions (in thousand metric tons of CO2 equivalent) of 2005 in Slovenia to that in Sweden?
Offer a very short reply. 0.23. What is the ratio of the Emissions (in thousand metric tons of CO2 equivalent) of 2008 in Slovenia to that in Sweden?
Provide a succinct answer. 0.25. What is the ratio of the Emissions (in thousand metric tons of CO2 equivalent) in 1990 in Slovenia to that in Switzerland?
Your answer should be very brief. 0.85. What is the ratio of the Emissions (in thousand metric tons of CO2 equivalent) in 2000 in Slovenia to that in Switzerland?
Your response must be concise. 0.26. What is the ratio of the Emissions (in thousand metric tons of CO2 equivalent) in 2005 in Slovenia to that in Switzerland?
Make the answer very short. 0.23. What is the ratio of the Emissions (in thousand metric tons of CO2 equivalent) in 2008 in Slovenia to that in Switzerland?
Make the answer very short. 0.22. What is the ratio of the Emissions (in thousand metric tons of CO2 equivalent) in 1990 in South Africa to that in Spain?
Provide a succinct answer. 0.24. What is the ratio of the Emissions (in thousand metric tons of CO2 equivalent) of 2000 in South Africa to that in Spain?
Offer a very short reply. 0.22. What is the ratio of the Emissions (in thousand metric tons of CO2 equivalent) of 2005 in South Africa to that in Spain?
Ensure brevity in your answer.  0.28. What is the ratio of the Emissions (in thousand metric tons of CO2 equivalent) in 2008 in South Africa to that in Spain?
Offer a very short reply. 0.26. What is the ratio of the Emissions (in thousand metric tons of CO2 equivalent) of 1990 in South Africa to that in Sweden?
Offer a terse response. 1.68. What is the ratio of the Emissions (in thousand metric tons of CO2 equivalent) in 2000 in South Africa to that in Sweden?
Provide a short and direct response. 1.16. What is the ratio of the Emissions (in thousand metric tons of CO2 equivalent) in 2005 in South Africa to that in Sweden?
Your response must be concise. 1.23. What is the ratio of the Emissions (in thousand metric tons of CO2 equivalent) in 2008 in South Africa to that in Sweden?
Your answer should be compact. 1.25. What is the ratio of the Emissions (in thousand metric tons of CO2 equivalent) in 1990 in South Africa to that in Switzerland?
Give a very brief answer. 1.65. What is the ratio of the Emissions (in thousand metric tons of CO2 equivalent) of 2000 in South Africa to that in Switzerland?
Offer a terse response. 1.4. What is the ratio of the Emissions (in thousand metric tons of CO2 equivalent) in 2005 in South Africa to that in Switzerland?
Make the answer very short. 1.26. What is the ratio of the Emissions (in thousand metric tons of CO2 equivalent) of 2008 in South Africa to that in Switzerland?
Give a very brief answer. 1.11. What is the ratio of the Emissions (in thousand metric tons of CO2 equivalent) in 1990 in Spain to that in Sweden?
Offer a terse response. 6.92. What is the ratio of the Emissions (in thousand metric tons of CO2 equivalent) in 2000 in Spain to that in Sweden?
Offer a terse response. 5.41. What is the ratio of the Emissions (in thousand metric tons of CO2 equivalent) in 2005 in Spain to that in Sweden?
Keep it short and to the point. 4.38. What is the ratio of the Emissions (in thousand metric tons of CO2 equivalent) of 2008 in Spain to that in Sweden?
Offer a terse response. 4.85. What is the ratio of the Emissions (in thousand metric tons of CO2 equivalent) in 1990 in Spain to that in Switzerland?
Keep it short and to the point. 6.81. What is the ratio of the Emissions (in thousand metric tons of CO2 equivalent) in 2000 in Spain to that in Switzerland?
Give a very brief answer. 6.49. What is the ratio of the Emissions (in thousand metric tons of CO2 equivalent) of 2005 in Spain to that in Switzerland?
Your response must be concise. 4.47. What is the ratio of the Emissions (in thousand metric tons of CO2 equivalent) of 2008 in Spain to that in Switzerland?
Your answer should be compact. 4.31. What is the ratio of the Emissions (in thousand metric tons of CO2 equivalent) of 1990 in Sweden to that in Switzerland?
Provide a succinct answer. 0.98. What is the ratio of the Emissions (in thousand metric tons of CO2 equivalent) of 2000 in Sweden to that in Switzerland?
Your response must be concise. 1.2. What is the ratio of the Emissions (in thousand metric tons of CO2 equivalent) of 2005 in Sweden to that in Switzerland?
Your answer should be very brief. 1.02. What is the ratio of the Emissions (in thousand metric tons of CO2 equivalent) in 2008 in Sweden to that in Switzerland?
Ensure brevity in your answer.  0.89. What is the difference between the highest and the second highest Emissions (in thousand metric tons of CO2 equivalent) of 1990?
Provide a short and direct response. 4654.9. What is the difference between the highest and the second highest Emissions (in thousand metric tons of CO2 equivalent) in 2000?
Give a very brief answer. 6308.3. What is the difference between the highest and the second highest Emissions (in thousand metric tons of CO2 equivalent) of 2005?
Give a very brief answer. 6511.1. What is the difference between the highest and the second highest Emissions (in thousand metric tons of CO2 equivalent) in 2008?
Keep it short and to the point. 8433.4. What is the difference between the highest and the lowest Emissions (in thousand metric tons of CO2 equivalent) of 1990?
Ensure brevity in your answer.  6077.7. What is the difference between the highest and the lowest Emissions (in thousand metric tons of CO2 equivalent) in 2000?
Keep it short and to the point. 7851.5. What is the difference between the highest and the lowest Emissions (in thousand metric tons of CO2 equivalent) of 2005?
Give a very brief answer. 8663.8. What is the difference between the highest and the lowest Emissions (in thousand metric tons of CO2 equivalent) of 2008?
Provide a succinct answer. 1.08e+04. 